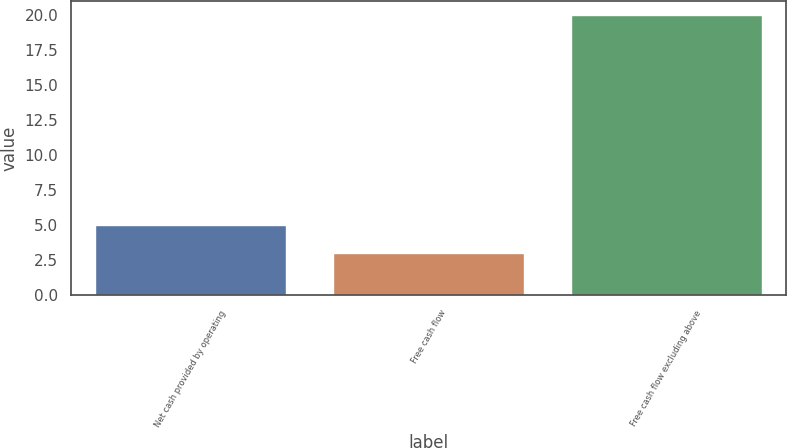Convert chart. <chart><loc_0><loc_0><loc_500><loc_500><bar_chart><fcel>Net cash provided by operating<fcel>Free cash flow<fcel>Free cash flow excluding above<nl><fcel>5<fcel>3<fcel>20<nl></chart> 